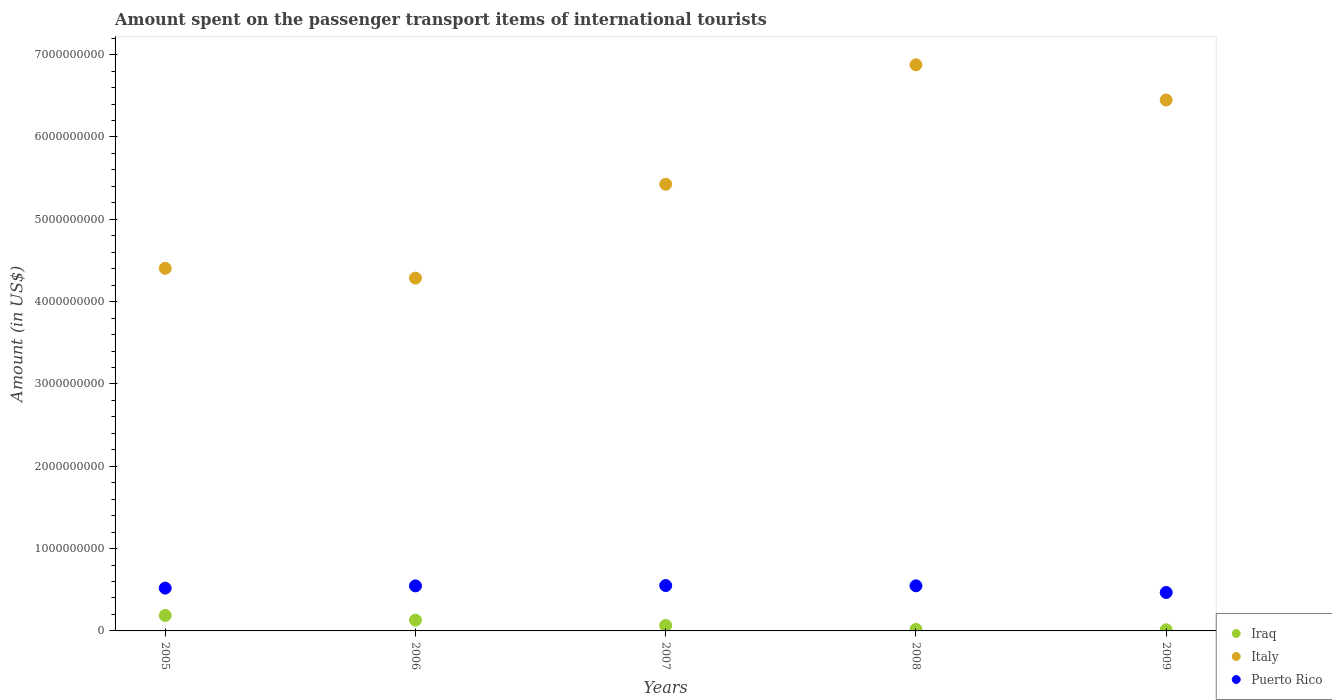Is the number of dotlines equal to the number of legend labels?
Offer a terse response. Yes. What is the amount spent on the passenger transport items of international tourists in Italy in 2006?
Offer a very short reply. 4.28e+09. Across all years, what is the maximum amount spent on the passenger transport items of international tourists in Italy?
Your response must be concise. 6.88e+09. Across all years, what is the minimum amount spent on the passenger transport items of international tourists in Italy?
Give a very brief answer. 4.28e+09. What is the total amount spent on the passenger transport items of international tourists in Italy in the graph?
Your answer should be very brief. 2.74e+1. What is the difference between the amount spent on the passenger transport items of international tourists in Italy in 2008 and that in 2009?
Provide a succinct answer. 4.27e+08. What is the difference between the amount spent on the passenger transport items of international tourists in Puerto Rico in 2006 and the amount spent on the passenger transport items of international tourists in Iraq in 2005?
Give a very brief answer. 3.59e+08. What is the average amount spent on the passenger transport items of international tourists in Puerto Rico per year?
Make the answer very short. 5.27e+08. In the year 2007, what is the difference between the amount spent on the passenger transport items of international tourists in Iraq and amount spent on the passenger transport items of international tourists in Puerto Rico?
Offer a very short reply. -4.85e+08. In how many years, is the amount spent on the passenger transport items of international tourists in Italy greater than 4000000000 US$?
Offer a very short reply. 5. What is the ratio of the amount spent on the passenger transport items of international tourists in Italy in 2005 to that in 2007?
Give a very brief answer. 0.81. Is the amount spent on the passenger transport items of international tourists in Italy in 2005 less than that in 2009?
Give a very brief answer. Yes. What is the difference between the highest and the second highest amount spent on the passenger transport items of international tourists in Italy?
Ensure brevity in your answer.  4.27e+08. What is the difference between the highest and the lowest amount spent on the passenger transport items of international tourists in Italy?
Ensure brevity in your answer.  2.59e+09. Is it the case that in every year, the sum of the amount spent on the passenger transport items of international tourists in Italy and amount spent on the passenger transport items of international tourists in Iraq  is greater than the amount spent on the passenger transport items of international tourists in Puerto Rico?
Your response must be concise. Yes. Does the amount spent on the passenger transport items of international tourists in Puerto Rico monotonically increase over the years?
Provide a short and direct response. No. Is the amount spent on the passenger transport items of international tourists in Puerto Rico strictly greater than the amount spent on the passenger transport items of international tourists in Iraq over the years?
Provide a succinct answer. Yes. Is the amount spent on the passenger transport items of international tourists in Italy strictly less than the amount spent on the passenger transport items of international tourists in Puerto Rico over the years?
Provide a short and direct response. No. How many years are there in the graph?
Ensure brevity in your answer.  5. What is the difference between two consecutive major ticks on the Y-axis?
Provide a succinct answer. 1.00e+09. Does the graph contain any zero values?
Your answer should be very brief. No. How many legend labels are there?
Provide a short and direct response. 3. What is the title of the graph?
Your answer should be very brief. Amount spent on the passenger transport items of international tourists. What is the Amount (in US$) of Iraq in 2005?
Ensure brevity in your answer.  1.88e+08. What is the Amount (in US$) of Italy in 2005?
Offer a very short reply. 4.40e+09. What is the Amount (in US$) in Puerto Rico in 2005?
Provide a succinct answer. 5.20e+08. What is the Amount (in US$) of Iraq in 2006?
Ensure brevity in your answer.  1.31e+08. What is the Amount (in US$) of Italy in 2006?
Your response must be concise. 4.28e+09. What is the Amount (in US$) of Puerto Rico in 2006?
Provide a short and direct response. 5.47e+08. What is the Amount (in US$) of Iraq in 2007?
Provide a short and direct response. 6.60e+07. What is the Amount (in US$) in Italy in 2007?
Offer a very short reply. 5.42e+09. What is the Amount (in US$) of Puerto Rico in 2007?
Make the answer very short. 5.51e+08. What is the Amount (in US$) of Iraq in 2008?
Provide a succinct answer. 1.90e+07. What is the Amount (in US$) of Italy in 2008?
Offer a terse response. 6.88e+09. What is the Amount (in US$) in Puerto Rico in 2008?
Your response must be concise. 5.48e+08. What is the Amount (in US$) in Iraq in 2009?
Provide a succinct answer. 1.40e+07. What is the Amount (in US$) in Italy in 2009?
Give a very brief answer. 6.45e+09. What is the Amount (in US$) of Puerto Rico in 2009?
Keep it short and to the point. 4.67e+08. Across all years, what is the maximum Amount (in US$) in Iraq?
Keep it short and to the point. 1.88e+08. Across all years, what is the maximum Amount (in US$) of Italy?
Give a very brief answer. 6.88e+09. Across all years, what is the maximum Amount (in US$) of Puerto Rico?
Provide a succinct answer. 5.51e+08. Across all years, what is the minimum Amount (in US$) in Iraq?
Make the answer very short. 1.40e+07. Across all years, what is the minimum Amount (in US$) in Italy?
Provide a succinct answer. 4.28e+09. Across all years, what is the minimum Amount (in US$) in Puerto Rico?
Provide a short and direct response. 4.67e+08. What is the total Amount (in US$) in Iraq in the graph?
Your response must be concise. 4.18e+08. What is the total Amount (in US$) in Italy in the graph?
Provide a short and direct response. 2.74e+1. What is the total Amount (in US$) in Puerto Rico in the graph?
Keep it short and to the point. 2.63e+09. What is the difference between the Amount (in US$) in Iraq in 2005 and that in 2006?
Provide a succinct answer. 5.70e+07. What is the difference between the Amount (in US$) in Italy in 2005 and that in 2006?
Offer a very short reply. 1.19e+08. What is the difference between the Amount (in US$) of Puerto Rico in 2005 and that in 2006?
Your answer should be very brief. -2.70e+07. What is the difference between the Amount (in US$) of Iraq in 2005 and that in 2007?
Offer a very short reply. 1.22e+08. What is the difference between the Amount (in US$) of Italy in 2005 and that in 2007?
Offer a very short reply. -1.02e+09. What is the difference between the Amount (in US$) in Puerto Rico in 2005 and that in 2007?
Provide a succinct answer. -3.10e+07. What is the difference between the Amount (in US$) in Iraq in 2005 and that in 2008?
Provide a succinct answer. 1.69e+08. What is the difference between the Amount (in US$) of Italy in 2005 and that in 2008?
Your answer should be very brief. -2.47e+09. What is the difference between the Amount (in US$) of Puerto Rico in 2005 and that in 2008?
Make the answer very short. -2.80e+07. What is the difference between the Amount (in US$) in Iraq in 2005 and that in 2009?
Offer a very short reply. 1.74e+08. What is the difference between the Amount (in US$) of Italy in 2005 and that in 2009?
Provide a succinct answer. -2.04e+09. What is the difference between the Amount (in US$) of Puerto Rico in 2005 and that in 2009?
Ensure brevity in your answer.  5.30e+07. What is the difference between the Amount (in US$) in Iraq in 2006 and that in 2007?
Offer a terse response. 6.50e+07. What is the difference between the Amount (in US$) in Italy in 2006 and that in 2007?
Ensure brevity in your answer.  -1.14e+09. What is the difference between the Amount (in US$) in Puerto Rico in 2006 and that in 2007?
Give a very brief answer. -4.00e+06. What is the difference between the Amount (in US$) of Iraq in 2006 and that in 2008?
Make the answer very short. 1.12e+08. What is the difference between the Amount (in US$) in Italy in 2006 and that in 2008?
Your answer should be compact. -2.59e+09. What is the difference between the Amount (in US$) of Iraq in 2006 and that in 2009?
Make the answer very short. 1.17e+08. What is the difference between the Amount (in US$) of Italy in 2006 and that in 2009?
Make the answer very short. -2.16e+09. What is the difference between the Amount (in US$) in Puerto Rico in 2006 and that in 2009?
Keep it short and to the point. 8.00e+07. What is the difference between the Amount (in US$) in Iraq in 2007 and that in 2008?
Your answer should be very brief. 4.70e+07. What is the difference between the Amount (in US$) of Italy in 2007 and that in 2008?
Keep it short and to the point. -1.45e+09. What is the difference between the Amount (in US$) in Puerto Rico in 2007 and that in 2008?
Give a very brief answer. 3.00e+06. What is the difference between the Amount (in US$) of Iraq in 2007 and that in 2009?
Your answer should be compact. 5.20e+07. What is the difference between the Amount (in US$) of Italy in 2007 and that in 2009?
Keep it short and to the point. -1.02e+09. What is the difference between the Amount (in US$) of Puerto Rico in 2007 and that in 2009?
Your answer should be compact. 8.40e+07. What is the difference between the Amount (in US$) of Iraq in 2008 and that in 2009?
Ensure brevity in your answer.  5.00e+06. What is the difference between the Amount (in US$) of Italy in 2008 and that in 2009?
Make the answer very short. 4.27e+08. What is the difference between the Amount (in US$) of Puerto Rico in 2008 and that in 2009?
Your answer should be compact. 8.10e+07. What is the difference between the Amount (in US$) of Iraq in 2005 and the Amount (in US$) of Italy in 2006?
Make the answer very short. -4.10e+09. What is the difference between the Amount (in US$) of Iraq in 2005 and the Amount (in US$) of Puerto Rico in 2006?
Offer a very short reply. -3.59e+08. What is the difference between the Amount (in US$) in Italy in 2005 and the Amount (in US$) in Puerto Rico in 2006?
Offer a terse response. 3.86e+09. What is the difference between the Amount (in US$) of Iraq in 2005 and the Amount (in US$) of Italy in 2007?
Keep it short and to the point. -5.24e+09. What is the difference between the Amount (in US$) in Iraq in 2005 and the Amount (in US$) in Puerto Rico in 2007?
Provide a short and direct response. -3.63e+08. What is the difference between the Amount (in US$) in Italy in 2005 and the Amount (in US$) in Puerto Rico in 2007?
Make the answer very short. 3.85e+09. What is the difference between the Amount (in US$) of Iraq in 2005 and the Amount (in US$) of Italy in 2008?
Your answer should be compact. -6.69e+09. What is the difference between the Amount (in US$) in Iraq in 2005 and the Amount (in US$) in Puerto Rico in 2008?
Ensure brevity in your answer.  -3.60e+08. What is the difference between the Amount (in US$) of Italy in 2005 and the Amount (in US$) of Puerto Rico in 2008?
Ensure brevity in your answer.  3.86e+09. What is the difference between the Amount (in US$) of Iraq in 2005 and the Amount (in US$) of Italy in 2009?
Keep it short and to the point. -6.26e+09. What is the difference between the Amount (in US$) of Iraq in 2005 and the Amount (in US$) of Puerto Rico in 2009?
Your response must be concise. -2.79e+08. What is the difference between the Amount (in US$) of Italy in 2005 and the Amount (in US$) of Puerto Rico in 2009?
Offer a terse response. 3.94e+09. What is the difference between the Amount (in US$) of Iraq in 2006 and the Amount (in US$) of Italy in 2007?
Your answer should be very brief. -5.29e+09. What is the difference between the Amount (in US$) in Iraq in 2006 and the Amount (in US$) in Puerto Rico in 2007?
Keep it short and to the point. -4.20e+08. What is the difference between the Amount (in US$) in Italy in 2006 and the Amount (in US$) in Puerto Rico in 2007?
Your answer should be compact. 3.73e+09. What is the difference between the Amount (in US$) of Iraq in 2006 and the Amount (in US$) of Italy in 2008?
Your response must be concise. -6.74e+09. What is the difference between the Amount (in US$) in Iraq in 2006 and the Amount (in US$) in Puerto Rico in 2008?
Provide a short and direct response. -4.17e+08. What is the difference between the Amount (in US$) of Italy in 2006 and the Amount (in US$) of Puerto Rico in 2008?
Your answer should be very brief. 3.74e+09. What is the difference between the Amount (in US$) of Iraq in 2006 and the Amount (in US$) of Italy in 2009?
Make the answer very short. -6.32e+09. What is the difference between the Amount (in US$) of Iraq in 2006 and the Amount (in US$) of Puerto Rico in 2009?
Provide a short and direct response. -3.36e+08. What is the difference between the Amount (in US$) of Italy in 2006 and the Amount (in US$) of Puerto Rico in 2009?
Make the answer very short. 3.82e+09. What is the difference between the Amount (in US$) in Iraq in 2007 and the Amount (in US$) in Italy in 2008?
Give a very brief answer. -6.81e+09. What is the difference between the Amount (in US$) of Iraq in 2007 and the Amount (in US$) of Puerto Rico in 2008?
Make the answer very short. -4.82e+08. What is the difference between the Amount (in US$) of Italy in 2007 and the Amount (in US$) of Puerto Rico in 2008?
Provide a succinct answer. 4.88e+09. What is the difference between the Amount (in US$) in Iraq in 2007 and the Amount (in US$) in Italy in 2009?
Your answer should be very brief. -6.38e+09. What is the difference between the Amount (in US$) of Iraq in 2007 and the Amount (in US$) of Puerto Rico in 2009?
Provide a succinct answer. -4.01e+08. What is the difference between the Amount (in US$) in Italy in 2007 and the Amount (in US$) in Puerto Rico in 2009?
Provide a short and direct response. 4.96e+09. What is the difference between the Amount (in US$) of Iraq in 2008 and the Amount (in US$) of Italy in 2009?
Ensure brevity in your answer.  -6.43e+09. What is the difference between the Amount (in US$) in Iraq in 2008 and the Amount (in US$) in Puerto Rico in 2009?
Provide a succinct answer. -4.48e+08. What is the difference between the Amount (in US$) of Italy in 2008 and the Amount (in US$) of Puerto Rico in 2009?
Provide a succinct answer. 6.41e+09. What is the average Amount (in US$) in Iraq per year?
Ensure brevity in your answer.  8.36e+07. What is the average Amount (in US$) in Italy per year?
Your response must be concise. 5.49e+09. What is the average Amount (in US$) in Puerto Rico per year?
Make the answer very short. 5.27e+08. In the year 2005, what is the difference between the Amount (in US$) of Iraq and Amount (in US$) of Italy?
Make the answer very short. -4.22e+09. In the year 2005, what is the difference between the Amount (in US$) of Iraq and Amount (in US$) of Puerto Rico?
Offer a terse response. -3.32e+08. In the year 2005, what is the difference between the Amount (in US$) in Italy and Amount (in US$) in Puerto Rico?
Give a very brief answer. 3.88e+09. In the year 2006, what is the difference between the Amount (in US$) in Iraq and Amount (in US$) in Italy?
Your response must be concise. -4.15e+09. In the year 2006, what is the difference between the Amount (in US$) in Iraq and Amount (in US$) in Puerto Rico?
Ensure brevity in your answer.  -4.16e+08. In the year 2006, what is the difference between the Amount (in US$) of Italy and Amount (in US$) of Puerto Rico?
Give a very brief answer. 3.74e+09. In the year 2007, what is the difference between the Amount (in US$) of Iraq and Amount (in US$) of Italy?
Ensure brevity in your answer.  -5.36e+09. In the year 2007, what is the difference between the Amount (in US$) in Iraq and Amount (in US$) in Puerto Rico?
Your answer should be very brief. -4.85e+08. In the year 2007, what is the difference between the Amount (in US$) of Italy and Amount (in US$) of Puerto Rico?
Ensure brevity in your answer.  4.87e+09. In the year 2008, what is the difference between the Amount (in US$) in Iraq and Amount (in US$) in Italy?
Your answer should be compact. -6.86e+09. In the year 2008, what is the difference between the Amount (in US$) of Iraq and Amount (in US$) of Puerto Rico?
Ensure brevity in your answer.  -5.29e+08. In the year 2008, what is the difference between the Amount (in US$) of Italy and Amount (in US$) of Puerto Rico?
Make the answer very short. 6.33e+09. In the year 2009, what is the difference between the Amount (in US$) in Iraq and Amount (in US$) in Italy?
Ensure brevity in your answer.  -6.44e+09. In the year 2009, what is the difference between the Amount (in US$) of Iraq and Amount (in US$) of Puerto Rico?
Provide a short and direct response. -4.53e+08. In the year 2009, what is the difference between the Amount (in US$) in Italy and Amount (in US$) in Puerto Rico?
Your answer should be very brief. 5.98e+09. What is the ratio of the Amount (in US$) in Iraq in 2005 to that in 2006?
Your response must be concise. 1.44. What is the ratio of the Amount (in US$) in Italy in 2005 to that in 2006?
Ensure brevity in your answer.  1.03. What is the ratio of the Amount (in US$) of Puerto Rico in 2005 to that in 2006?
Keep it short and to the point. 0.95. What is the ratio of the Amount (in US$) of Iraq in 2005 to that in 2007?
Make the answer very short. 2.85. What is the ratio of the Amount (in US$) in Italy in 2005 to that in 2007?
Your response must be concise. 0.81. What is the ratio of the Amount (in US$) of Puerto Rico in 2005 to that in 2007?
Your response must be concise. 0.94. What is the ratio of the Amount (in US$) of Iraq in 2005 to that in 2008?
Offer a very short reply. 9.89. What is the ratio of the Amount (in US$) of Italy in 2005 to that in 2008?
Your answer should be compact. 0.64. What is the ratio of the Amount (in US$) of Puerto Rico in 2005 to that in 2008?
Your answer should be very brief. 0.95. What is the ratio of the Amount (in US$) in Iraq in 2005 to that in 2009?
Your answer should be very brief. 13.43. What is the ratio of the Amount (in US$) of Italy in 2005 to that in 2009?
Offer a very short reply. 0.68. What is the ratio of the Amount (in US$) of Puerto Rico in 2005 to that in 2009?
Offer a very short reply. 1.11. What is the ratio of the Amount (in US$) in Iraq in 2006 to that in 2007?
Your answer should be compact. 1.98. What is the ratio of the Amount (in US$) of Italy in 2006 to that in 2007?
Ensure brevity in your answer.  0.79. What is the ratio of the Amount (in US$) of Iraq in 2006 to that in 2008?
Keep it short and to the point. 6.89. What is the ratio of the Amount (in US$) of Italy in 2006 to that in 2008?
Offer a very short reply. 0.62. What is the ratio of the Amount (in US$) in Iraq in 2006 to that in 2009?
Give a very brief answer. 9.36. What is the ratio of the Amount (in US$) in Italy in 2006 to that in 2009?
Give a very brief answer. 0.66. What is the ratio of the Amount (in US$) in Puerto Rico in 2006 to that in 2009?
Make the answer very short. 1.17. What is the ratio of the Amount (in US$) of Iraq in 2007 to that in 2008?
Offer a terse response. 3.47. What is the ratio of the Amount (in US$) in Italy in 2007 to that in 2008?
Offer a very short reply. 0.79. What is the ratio of the Amount (in US$) of Iraq in 2007 to that in 2009?
Your answer should be very brief. 4.71. What is the ratio of the Amount (in US$) in Italy in 2007 to that in 2009?
Your response must be concise. 0.84. What is the ratio of the Amount (in US$) of Puerto Rico in 2007 to that in 2009?
Offer a terse response. 1.18. What is the ratio of the Amount (in US$) of Iraq in 2008 to that in 2009?
Your answer should be very brief. 1.36. What is the ratio of the Amount (in US$) of Italy in 2008 to that in 2009?
Your answer should be compact. 1.07. What is the ratio of the Amount (in US$) in Puerto Rico in 2008 to that in 2009?
Your answer should be very brief. 1.17. What is the difference between the highest and the second highest Amount (in US$) in Iraq?
Your answer should be very brief. 5.70e+07. What is the difference between the highest and the second highest Amount (in US$) of Italy?
Keep it short and to the point. 4.27e+08. What is the difference between the highest and the second highest Amount (in US$) in Puerto Rico?
Make the answer very short. 3.00e+06. What is the difference between the highest and the lowest Amount (in US$) of Iraq?
Provide a succinct answer. 1.74e+08. What is the difference between the highest and the lowest Amount (in US$) in Italy?
Ensure brevity in your answer.  2.59e+09. What is the difference between the highest and the lowest Amount (in US$) of Puerto Rico?
Provide a short and direct response. 8.40e+07. 